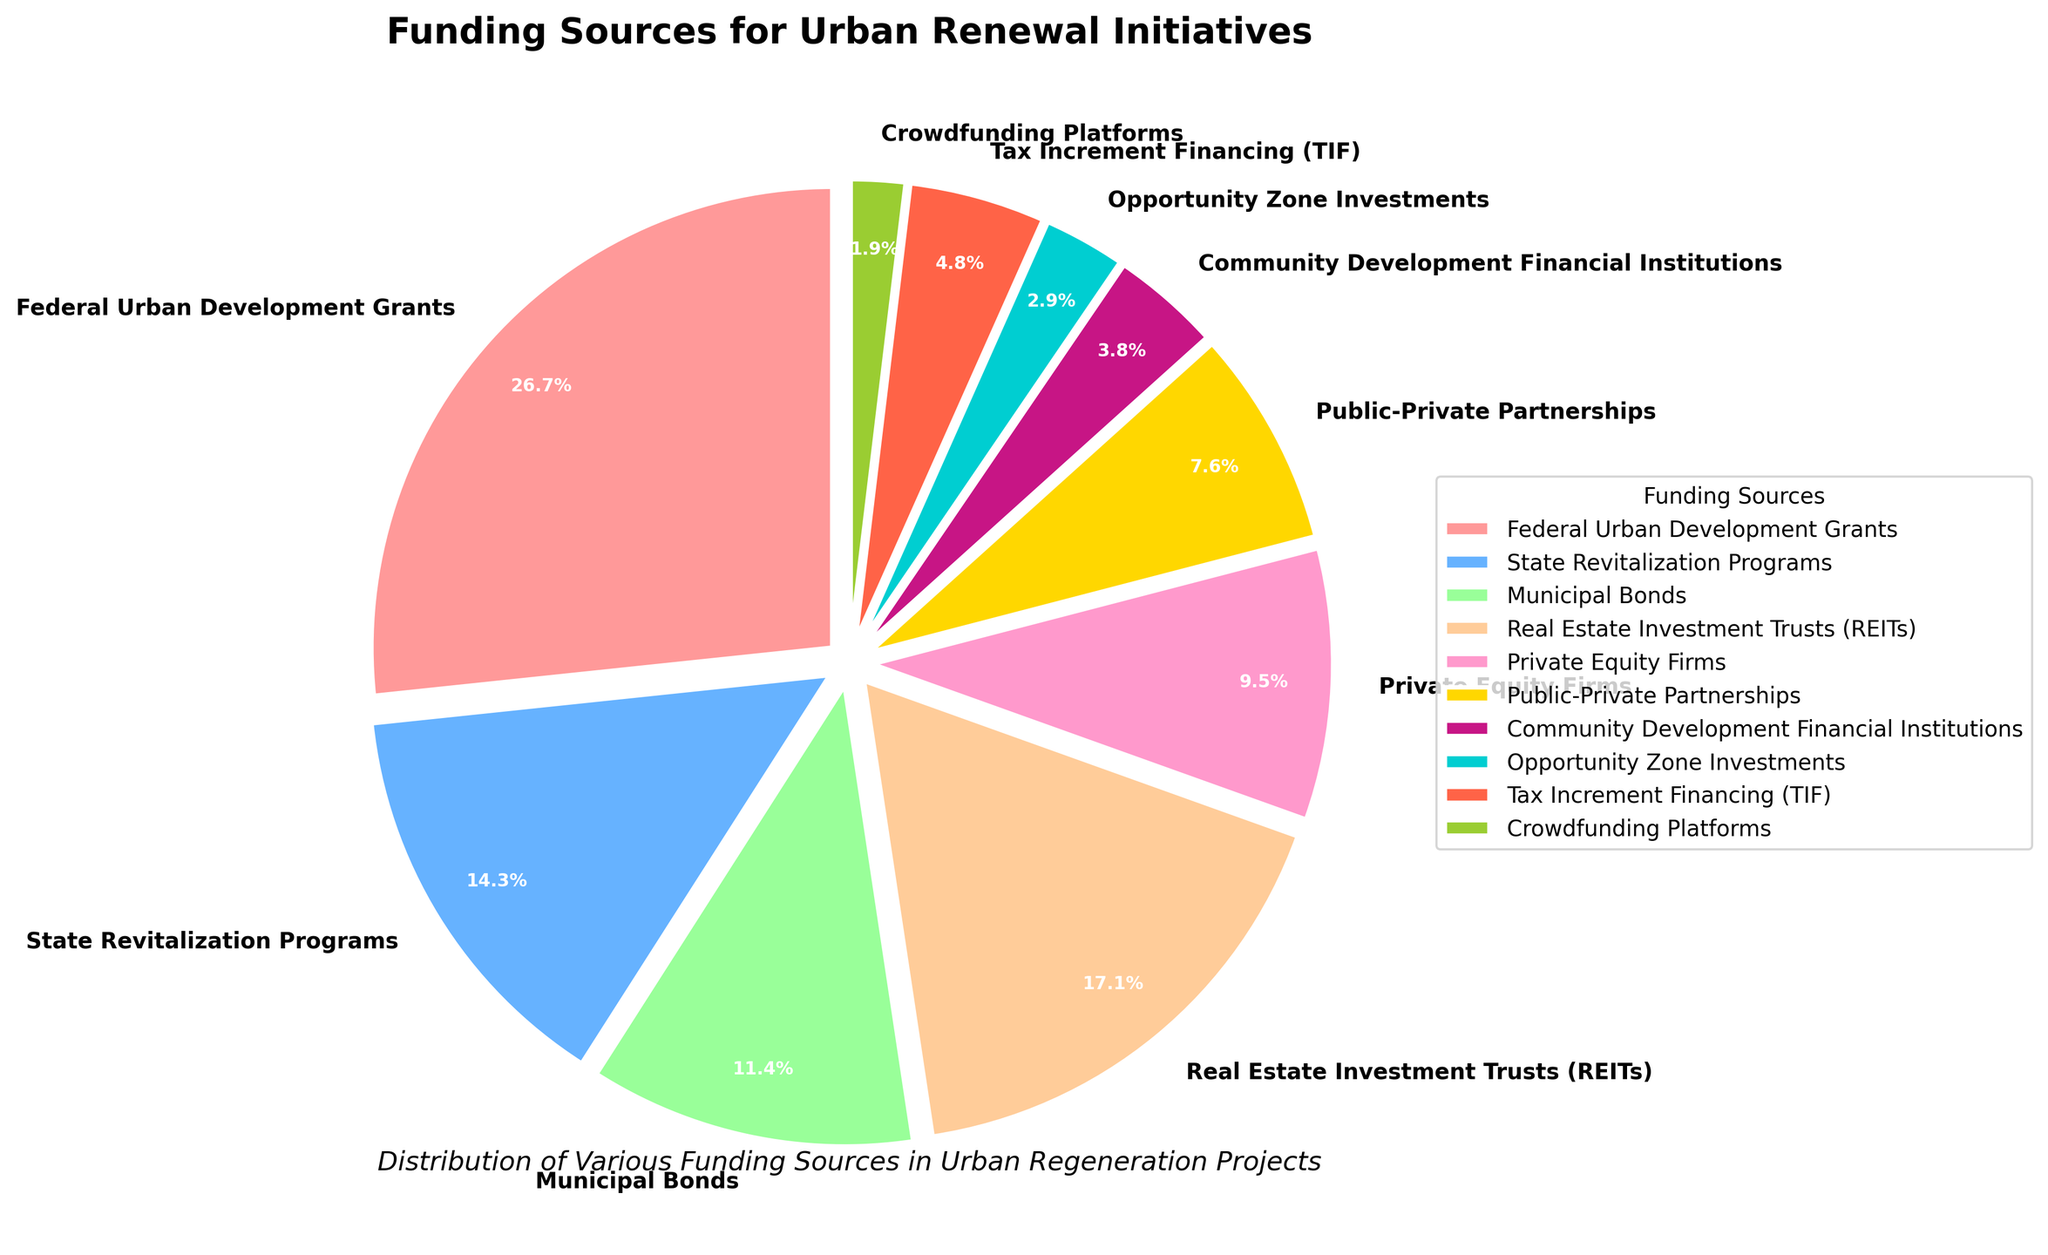What's the largest funding source for urban renewal initiatives? The largest wedge in the pie chart is labeled "Federal Urban Development Grants," which has the highest percentage.
Answer: Federal Urban Development Grants What's the difference in percentage between the funding from Federal Urban Development Grants and Real Estate Investment Trusts (REITs)? The percentage for Federal Urban Development Grants is 28%, and for REITs, it is 18%. The difference is calculated as 28% - 18%.
Answer: 10% What is the combined percentage of funding from Private Equity Firms and Crowdfunding Platforms? The percentage for Private Equity Firms is 10% and for Crowdfunding Platforms is 2%. Summing them up, 10% + 2% equals 12%.
Answer: 12% Which funding source has the smallest contribution to urban renewal initiatives? The smallest wedge in the pie chart is labeled "Crowdfunding Platforms," with a percentage of 2%.
Answer: Crowdfunding Platforms How much more funding do State Revitalization Programs receive compared to Tax Increment Financing (TIF)? The percentage for State Revitalization Programs is 15%, and for TIF, it is 5%. The difference is 15% - 5%.
Answer: 10% Among the top three funding sources, what is their combined percentage? The top three funding sources are Federal Urban Development Grants (28%), Real Estate Investment Trusts (18%), and State Revitalization Programs (15%). Add these percentages: 28% + 18% + 15% = 61%.
Answer: 61% What is the average percentage of funding received from Community Development Financial Institutions, Opportunity Zone Investments, and Crowdfunding Platforms? Add the percentages: 4% (CDFIs) + 3% (Opportunity Zone Investments) + 2% (Crowdfunding Platforms) = 9%. Then calculate the average: 9% / 3 = 3%.
Answer: 3% Which funding source ranks fourth in terms of contribution percentage? The fourth-largest wedge by percentage is labeled "Private Equity Firms," with a percentage of 10%.
Answer: Private Equity Firms What percentage of funding comes from public-private partnerships and municipal bonds combined? How does this compare to the funding from Real Estate Investment Trusts (REITs)? The combined percentage for Public-Private Partnerships (8%) and Municipal Bonds (12%) is 8% + 12% = 20%. REITs have a percentage of 18%. Compare the two values: 20% - 18% = 2%.
Answer: 20% combined, 2% higher 